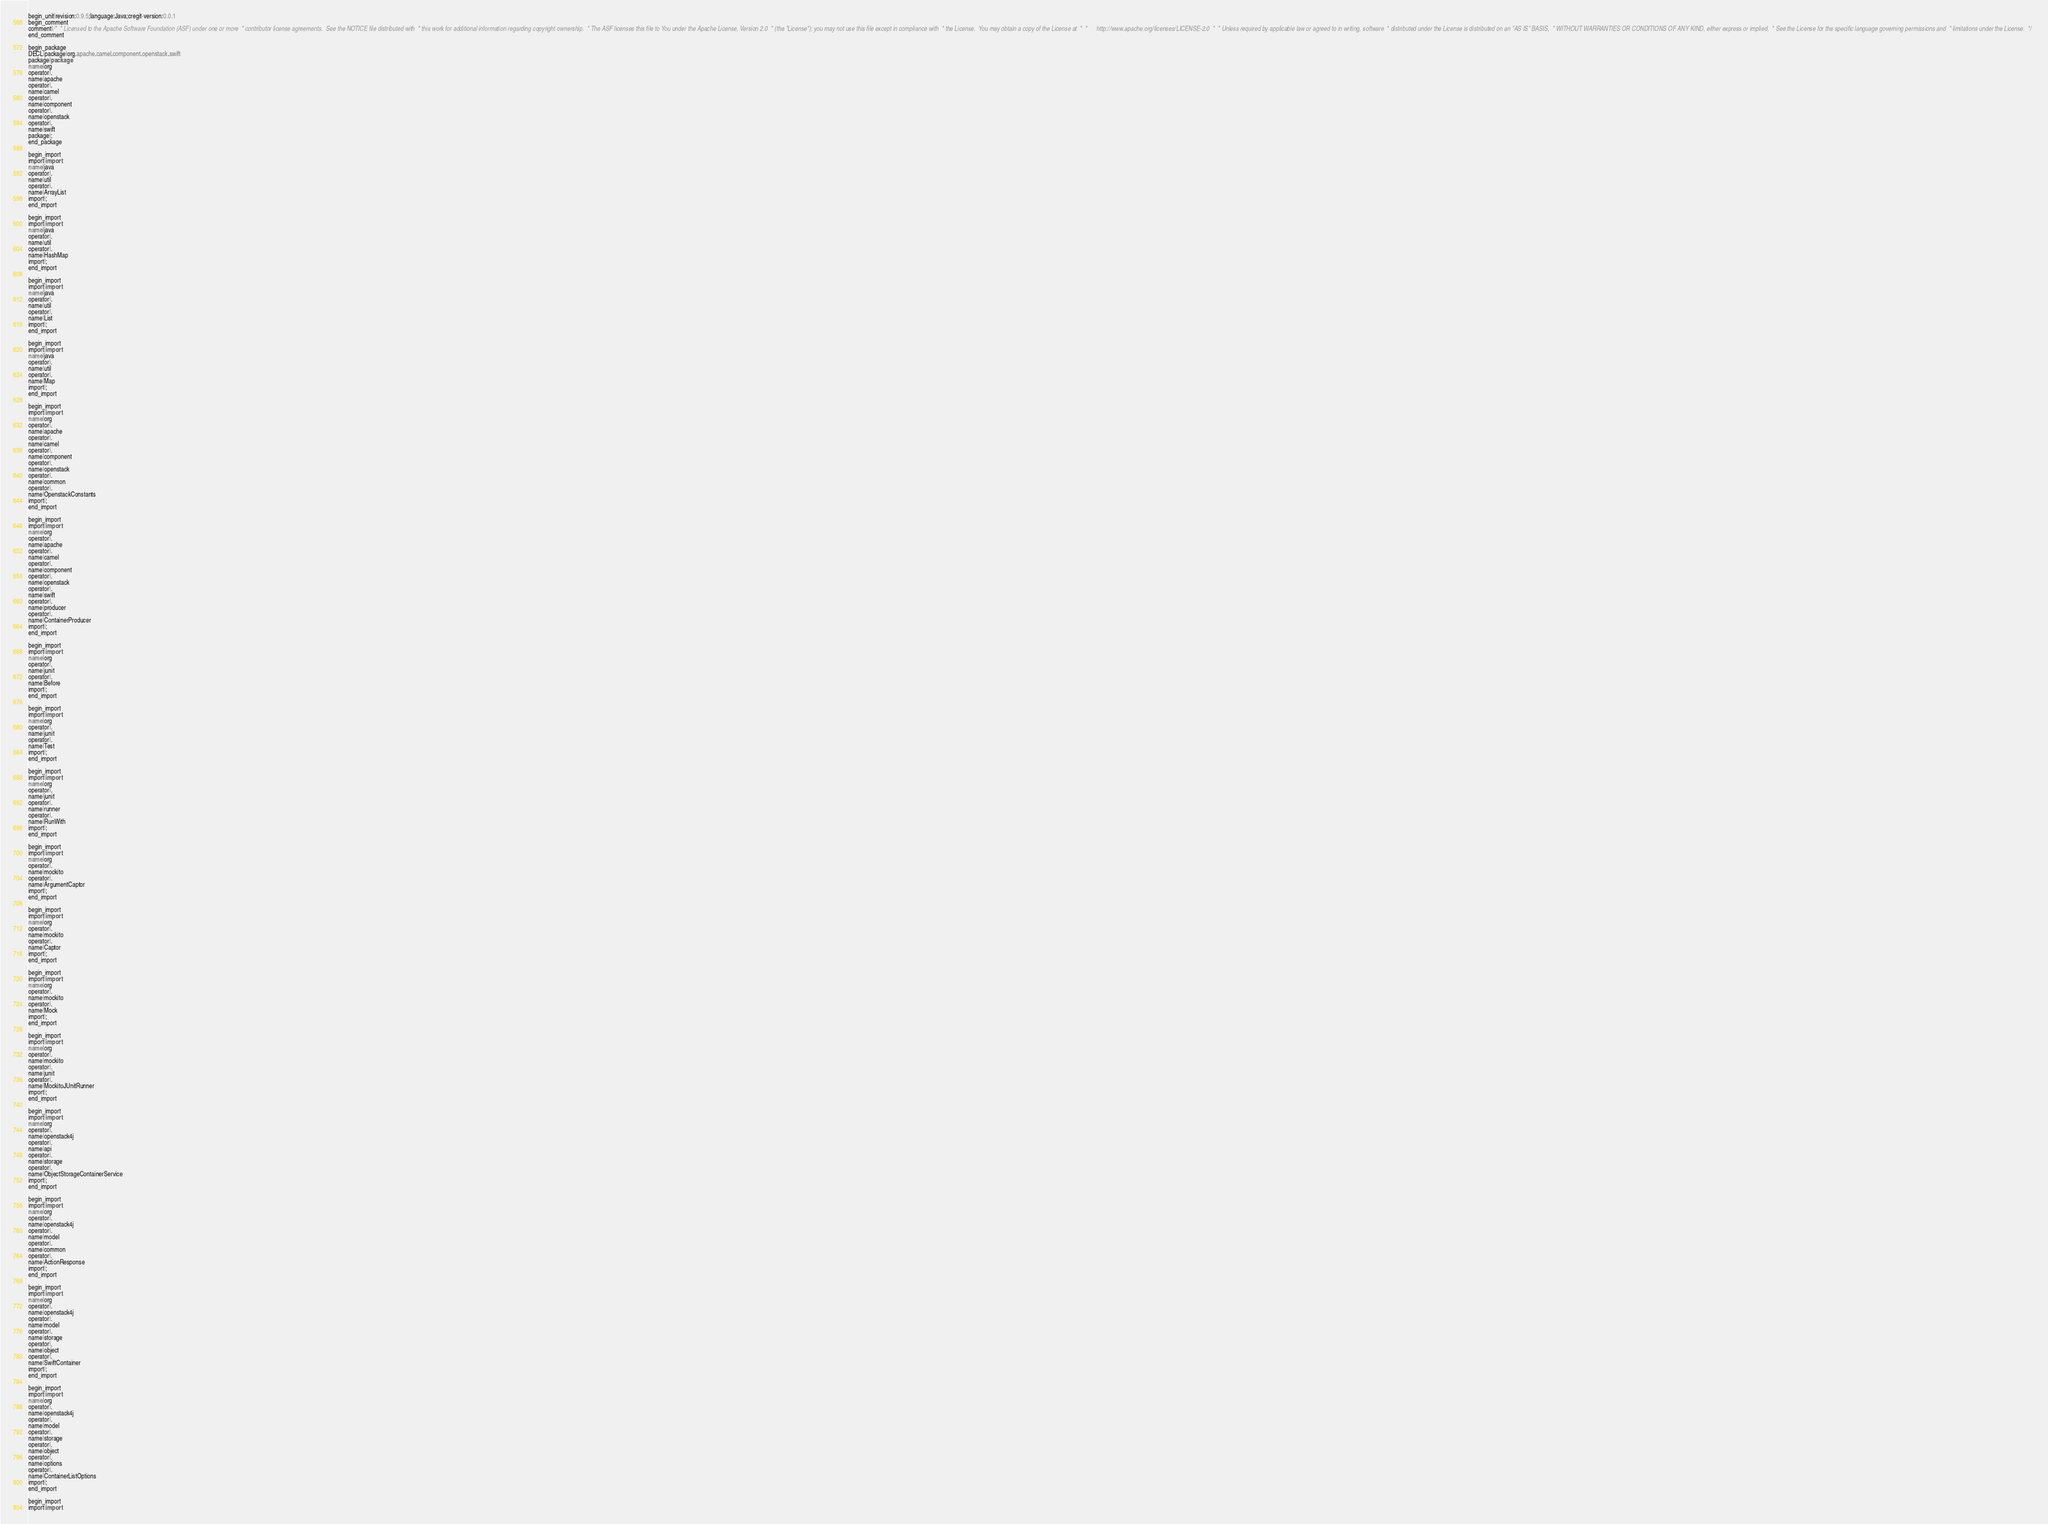<code> <loc_0><loc_0><loc_500><loc_500><_Java_>begin_unit|revision:0.9.5;language:Java;cregit-version:0.0.1
begin_comment
comment|/*  * Licensed to the Apache Software Foundation (ASF) under one or more  * contributor license agreements.  See the NOTICE file distributed with  * this work for additional information regarding copyright ownership.  * The ASF licenses this file to You under the Apache License, Version 2.0  * (the "License"); you may not use this file except in compliance with  * the License.  You may obtain a copy of the License at  *  *      http://www.apache.org/licenses/LICENSE-2.0  *  * Unless required by applicable law or agreed to in writing, software  * distributed under the License is distributed on an "AS IS" BASIS,  * WITHOUT WARRANTIES OR CONDITIONS OF ANY KIND, either express or implied.  * See the License for the specific language governing permissions and  * limitations under the License.  */
end_comment

begin_package
DECL|package|org.apache.camel.component.openstack.swift
package|package
name|org
operator|.
name|apache
operator|.
name|camel
operator|.
name|component
operator|.
name|openstack
operator|.
name|swift
package|;
end_package

begin_import
import|import
name|java
operator|.
name|util
operator|.
name|ArrayList
import|;
end_import

begin_import
import|import
name|java
operator|.
name|util
operator|.
name|HashMap
import|;
end_import

begin_import
import|import
name|java
operator|.
name|util
operator|.
name|List
import|;
end_import

begin_import
import|import
name|java
operator|.
name|util
operator|.
name|Map
import|;
end_import

begin_import
import|import
name|org
operator|.
name|apache
operator|.
name|camel
operator|.
name|component
operator|.
name|openstack
operator|.
name|common
operator|.
name|OpenstackConstants
import|;
end_import

begin_import
import|import
name|org
operator|.
name|apache
operator|.
name|camel
operator|.
name|component
operator|.
name|openstack
operator|.
name|swift
operator|.
name|producer
operator|.
name|ContainerProducer
import|;
end_import

begin_import
import|import
name|org
operator|.
name|junit
operator|.
name|Before
import|;
end_import

begin_import
import|import
name|org
operator|.
name|junit
operator|.
name|Test
import|;
end_import

begin_import
import|import
name|org
operator|.
name|junit
operator|.
name|runner
operator|.
name|RunWith
import|;
end_import

begin_import
import|import
name|org
operator|.
name|mockito
operator|.
name|ArgumentCaptor
import|;
end_import

begin_import
import|import
name|org
operator|.
name|mockito
operator|.
name|Captor
import|;
end_import

begin_import
import|import
name|org
operator|.
name|mockito
operator|.
name|Mock
import|;
end_import

begin_import
import|import
name|org
operator|.
name|mockito
operator|.
name|junit
operator|.
name|MockitoJUnitRunner
import|;
end_import

begin_import
import|import
name|org
operator|.
name|openstack4j
operator|.
name|api
operator|.
name|storage
operator|.
name|ObjectStorageContainerService
import|;
end_import

begin_import
import|import
name|org
operator|.
name|openstack4j
operator|.
name|model
operator|.
name|common
operator|.
name|ActionResponse
import|;
end_import

begin_import
import|import
name|org
operator|.
name|openstack4j
operator|.
name|model
operator|.
name|storage
operator|.
name|object
operator|.
name|SwiftContainer
import|;
end_import

begin_import
import|import
name|org
operator|.
name|openstack4j
operator|.
name|model
operator|.
name|storage
operator|.
name|object
operator|.
name|options
operator|.
name|ContainerListOptions
import|;
end_import

begin_import
import|import</code> 